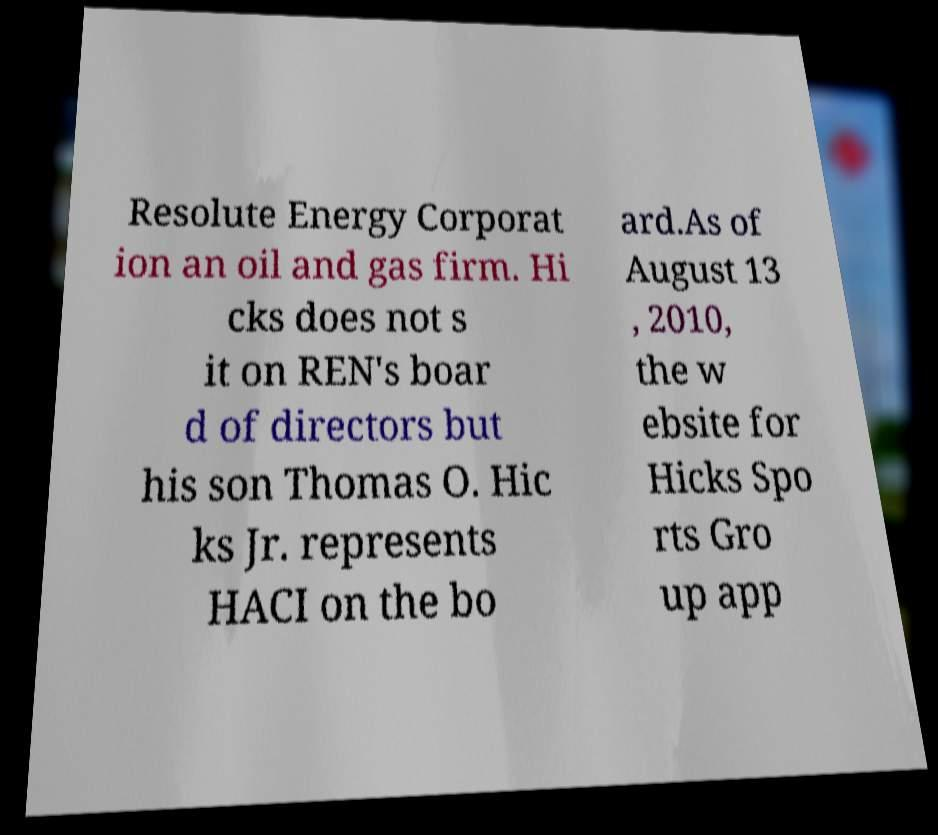For documentation purposes, I need the text within this image transcribed. Could you provide that? Resolute Energy Corporat ion an oil and gas firm. Hi cks does not s it on REN's boar d of directors but his son Thomas O. Hic ks Jr. represents HACI on the bo ard.As of August 13 , 2010, the w ebsite for Hicks Spo rts Gro up app 